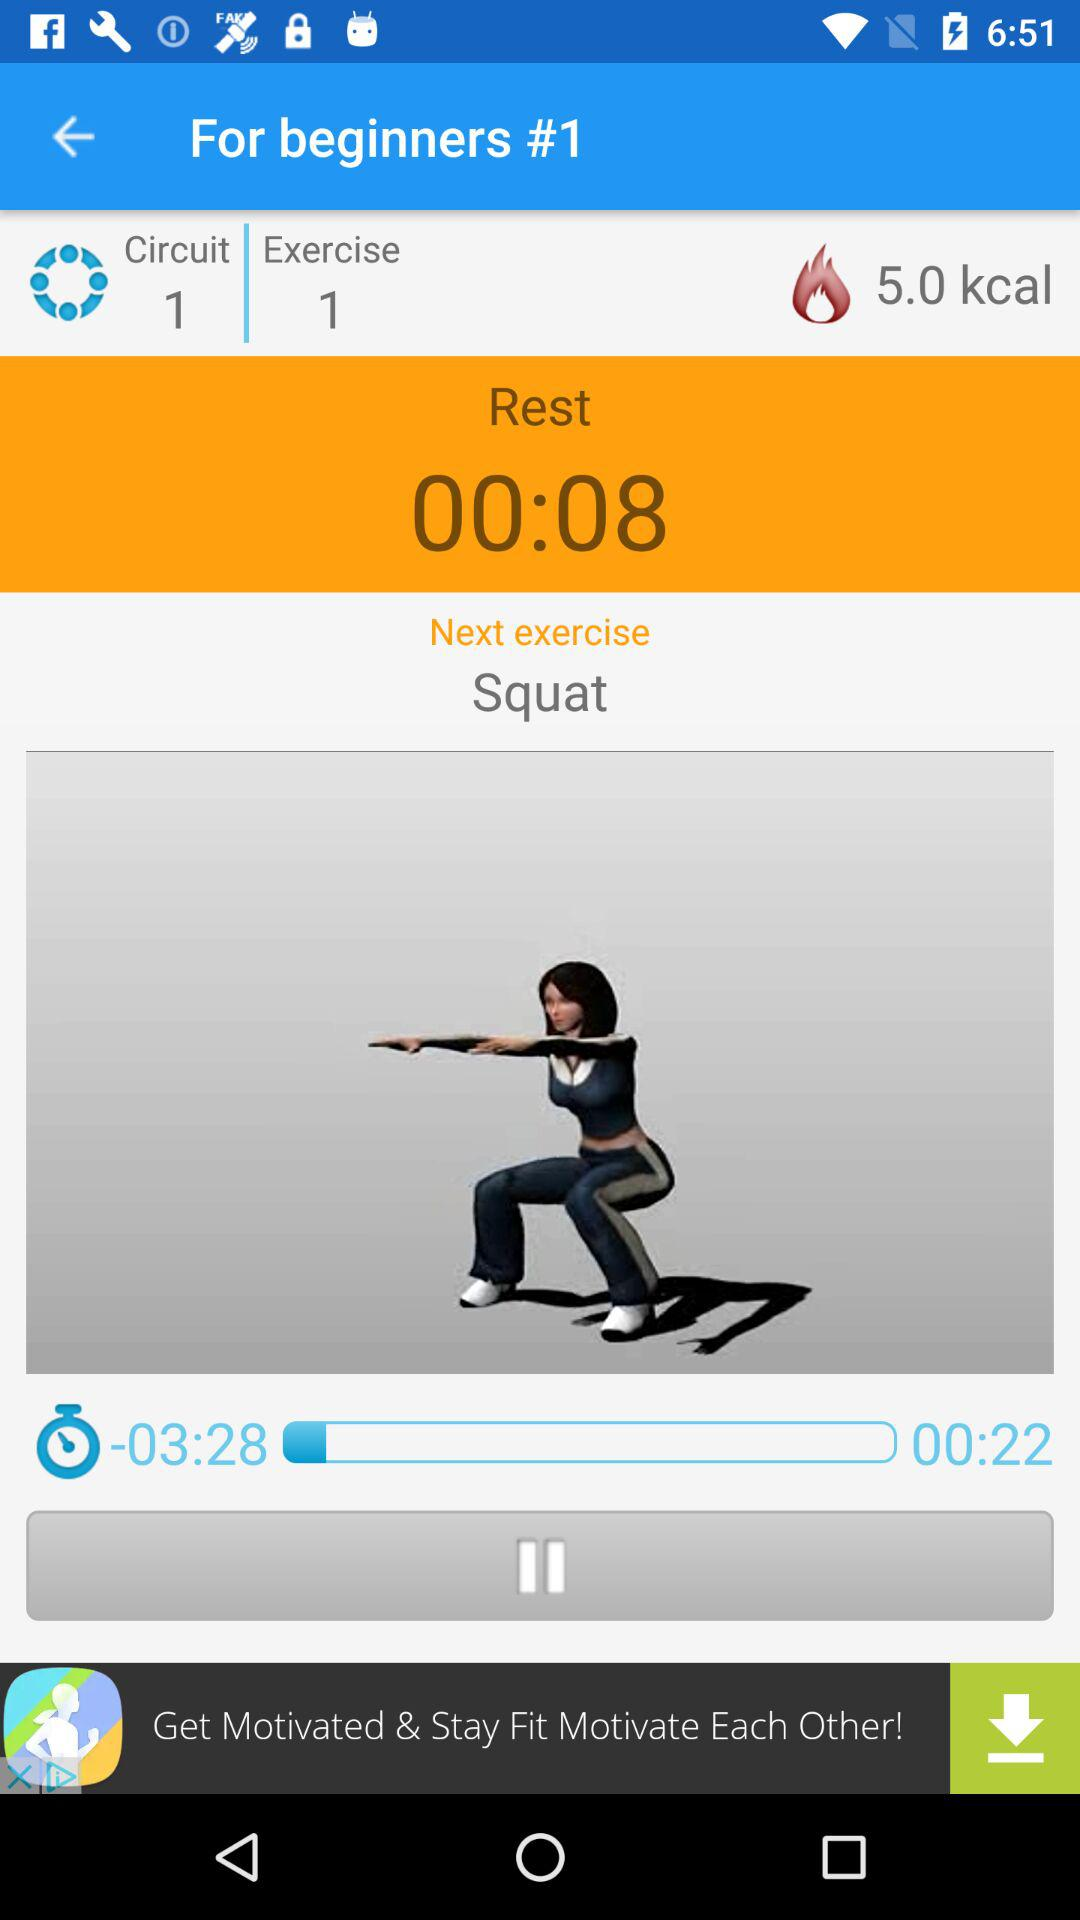For how long has the exercise been done? The exercise has been done for 22 seconds. 